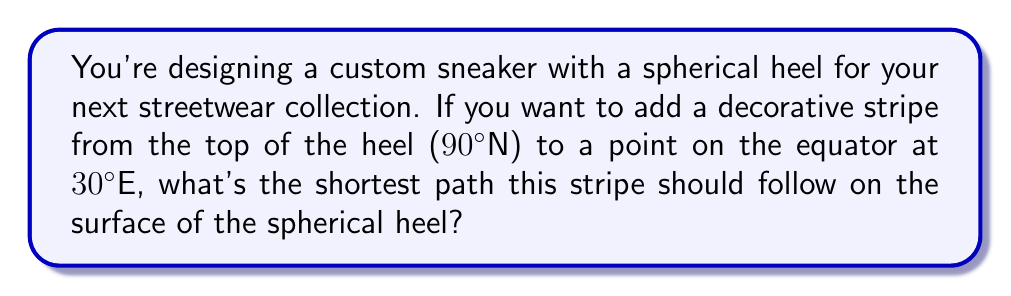Could you help me with this problem? To find the shortest path between two points on a curved surface, we need to use the concept of geodesics. On a sphere, the geodesic (shortest path) between any two points is a great circle.

Let's approach this step-by-step:

1) First, we need to understand that the starting point (top of the heel) is at 90°N latitude and the ending point is on the equator (0° latitude) at 30°E longitude.

2) The shortest path between these two points will follow a great circle that passes through both points.

3) In spherical geometry, this path is part of a great circle that intersects the sphere's axis at a right angle.

4) The angle between this great circle and the prime meridian (0° longitude) at the equator is the same as the longitude of the end point, which is 30°.

5) Therefore, the path will follow a great circle that starts at the North Pole (90°N), crosses all lines of longitude at right angles, and reaches the equator at 30°E.

6) This path is actually a meridian of longitude, specifically the 30°E meridian.

7) The path will trace a quarter of a great circle, starting from 90°N and ending at 0° latitude (equator).

[asy]
import geometry;

size(200);
pair O=(0,0);
real r=1;
draw(circle(O,r));
draw((-r,0)--(r,0),dashed);
draw((0,-r)--(0,r));
pair N=(0,r);
pair E=(r*cos(60),r*sin(60));
draw(N--E,red);
label("N",N,N);
label("30°E",E,E);
label("Equator",(-r,0),SW);
</asy]
Answer: The shortest path follows the 30°E meridian from 90°N to the equator. 